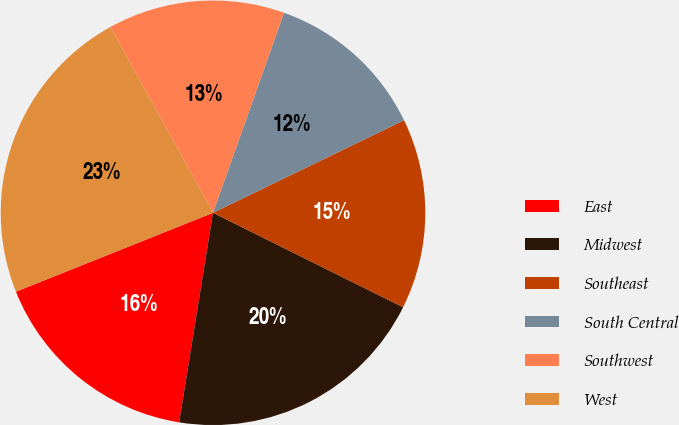<chart> <loc_0><loc_0><loc_500><loc_500><pie_chart><fcel>East<fcel>Midwest<fcel>Southeast<fcel>South Central<fcel>Southwest<fcel>West<nl><fcel>16.39%<fcel>20.21%<fcel>14.52%<fcel>12.39%<fcel>13.46%<fcel>23.03%<nl></chart> 